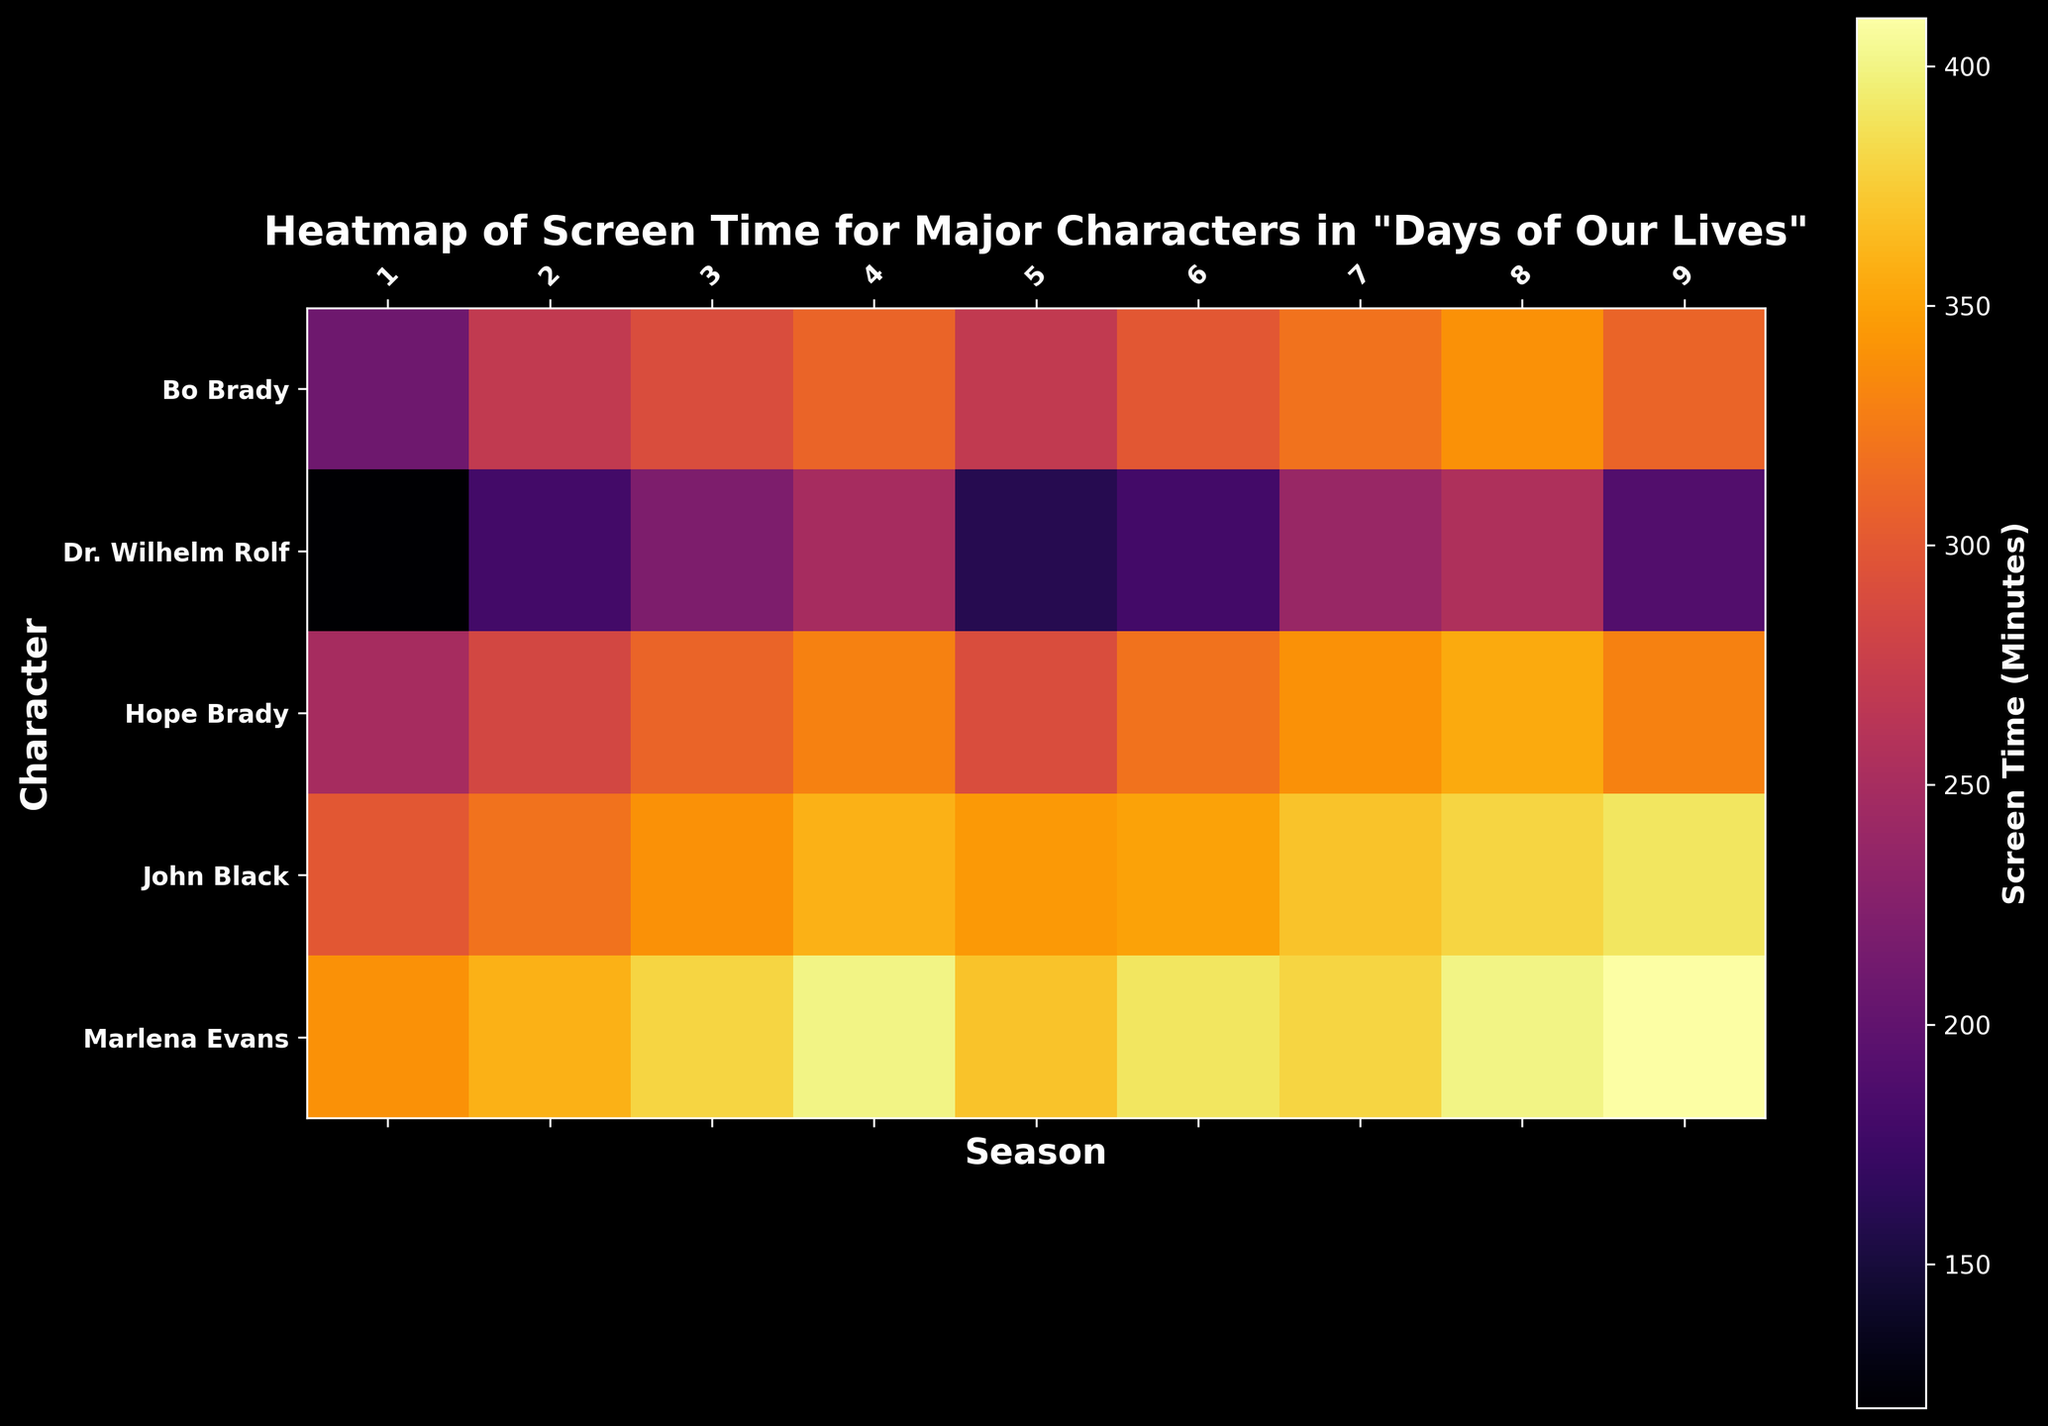Which season shows the most screen time for Dr. Wilhelm Rolf? First, locate Dr. Wilhelm Rolf on the y-axis. Then, look across the seasons on the x-axis to identify the season with the highest intensity color, which indicates the maximum screen time.
Answer: 8 In which season did Marlena Evans have the least screen time? Find Marlena Evans on the y-axis and compare the color intensity levels of her rows across the seasons. Identify the season with the least intense color.
Answer: 1 Who has more screen time in season 4, John Black or Bo Brady? Compare the colors representing screen time for John Black and Bo Brady in season 4. The character with the higher intensity color has more screen time.
Answer: John Black What's the difference in screen time between Hope Brady in season 1 and season 8? Identify the screen time color for Hope Brady in seasons 1 and 8. Note the values and calculate the difference: 355 (season 8) - 250 (season 1).
Answer: 105 Which character has the most consistent screen time throughout the seasons? Visually scan the rows to identify the character whose row shows minimal variation in color intensity across all seasons.
Answer: Marlena Evans During which two consecutive seasons does Dr. Wilhelm Rolf show the greatest increase in screen time? Compare the colors of Dr. Wilhelm Rolf in consecutive seasons to identify the transition where the color intensity increases the most.
Answer: Season 3 to Season 4 What is the average screen time for John Black over all seasons? Add the screen time values for John Black across all seasons: (300 + 320 + 340 + 360 + 345 + 350 + 370 + 380 + 390) and divide by the number of seasons (9).
Answer: 350 Which character has the lowest total screen time over all seasons? Sum up the screen time values for each character across all seasons and compare. The character with the lowest sum has the least total screen time.
Answer: Dr. Wilhelm Rolf How does the screen time in season 2 for Hope Brady compare to her screen time in season 1? Observe the transition of color intensity for Hope Brady from season 1 to season 2. Compare the two values directly: 285 (season 2) vs 250 (season 1).
Answer: Higher If we focus on seasons 5 to 7, who has the most screen time in these seasons? Sum the screen time values for each character from seasons 5, 6, and 7. The character with the highest total has the most screen time.
Answer: Marlena Evans 